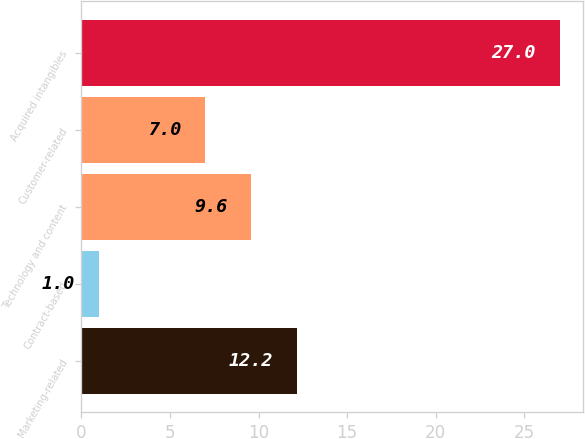Convert chart to OTSL. <chart><loc_0><loc_0><loc_500><loc_500><bar_chart><fcel>Marketing-related<fcel>Contract-based<fcel>Technology and content<fcel>Customer-related<fcel>Acquired intangibles<nl><fcel>12.2<fcel>1<fcel>9.6<fcel>7<fcel>27<nl></chart> 